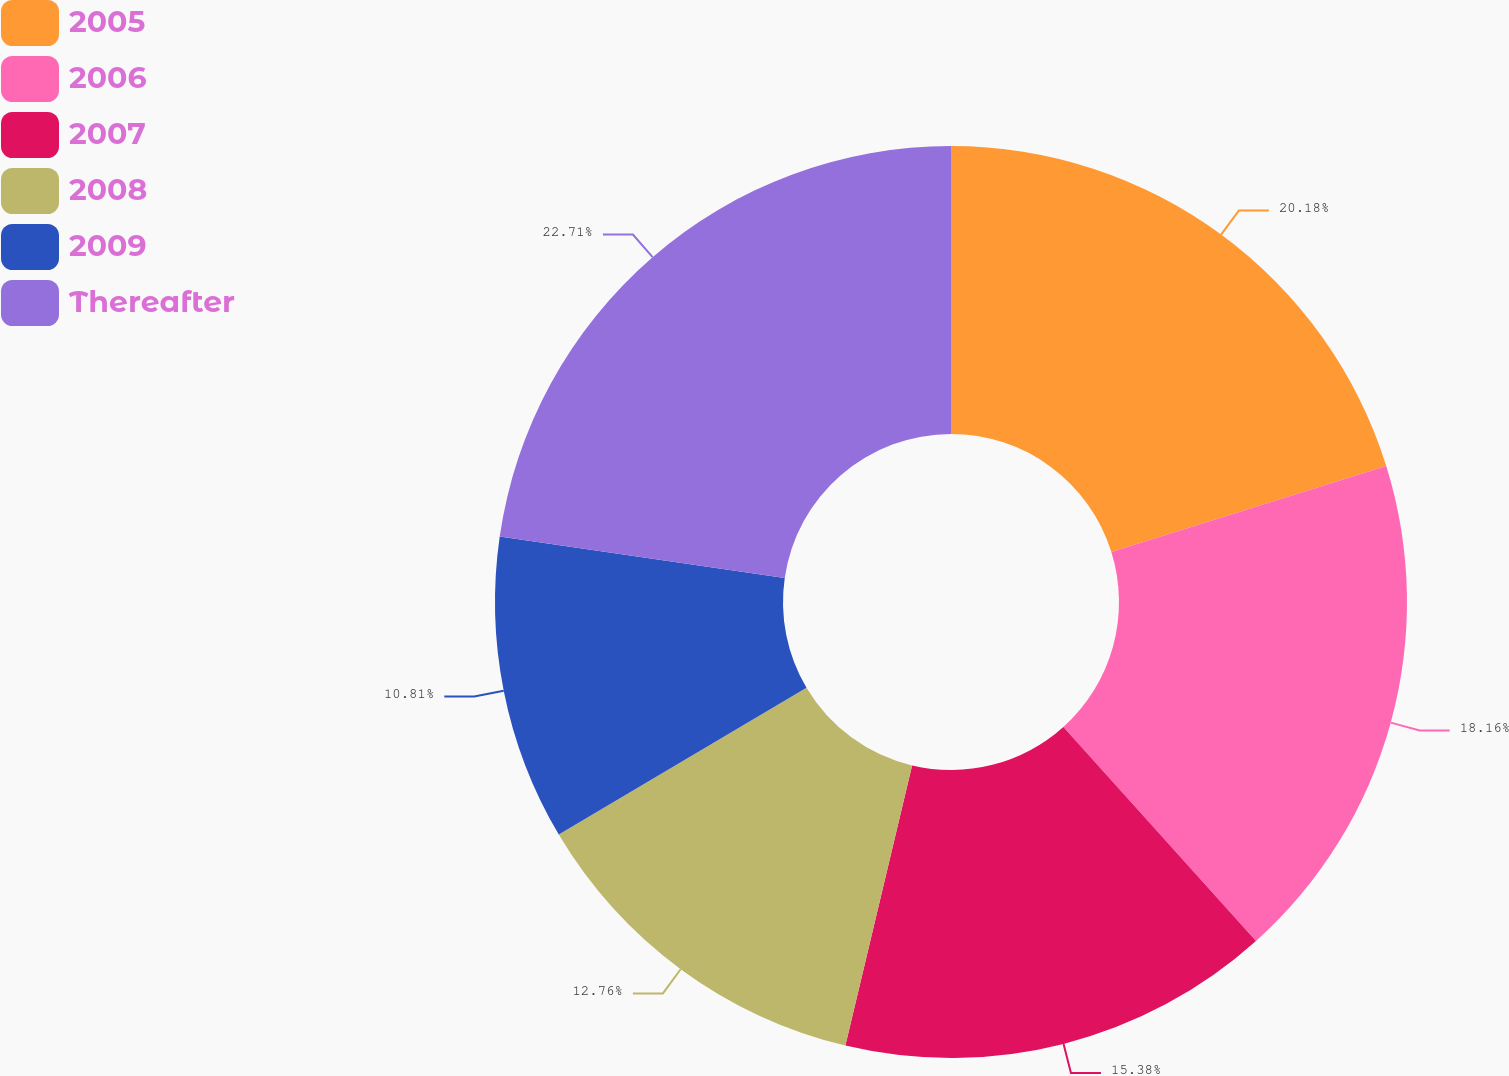<chart> <loc_0><loc_0><loc_500><loc_500><pie_chart><fcel>2005<fcel>2006<fcel>2007<fcel>2008<fcel>2009<fcel>Thereafter<nl><fcel>20.18%<fcel>18.16%<fcel>15.38%<fcel>12.76%<fcel>10.81%<fcel>22.71%<nl></chart> 